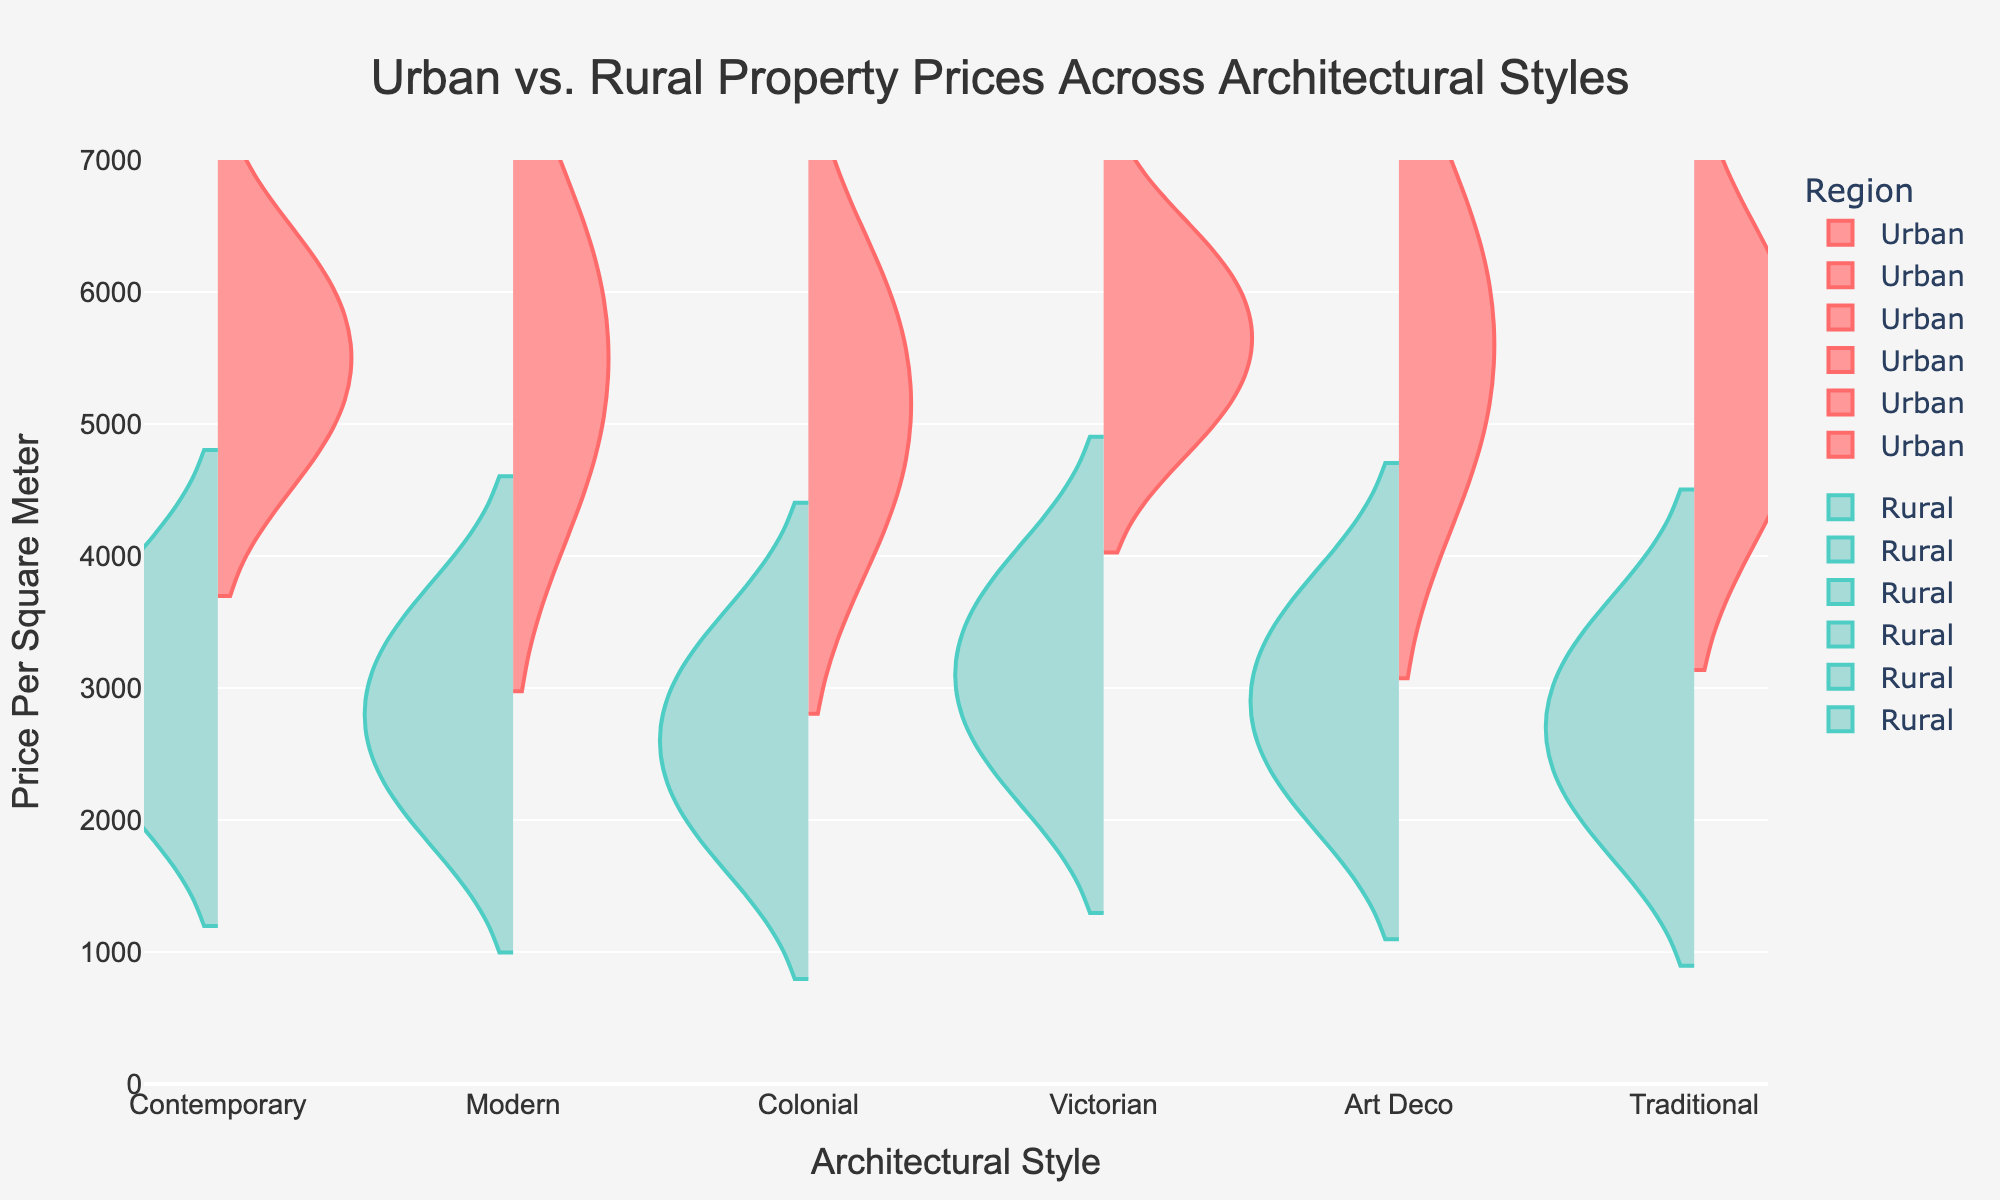Which region has higher property prices for Contemporary Architectural Style? To determine which region has higher property prices for the Contemporary Architectural Style, refer to the corresponding split violin shapes. The Urban section extends higher on the positive side than the Rural section on the negative side.
Answer: Urban What's the range of prices per square meter for Victorian Residential properties in urban areas? For Victorian Residential properties in urban areas, refer to the height of the positive split violin. The prices range from 0 to about 5200 per square meter.
Answer: 0 to 5200 Which architectural style has the smallest difference in property prices between urban and rural areas? Examine the overlap or proximity between the urban and rural segments of each Architectural Style. Art Deco has the smallest difference, with the urban prices slightly exceeding those of rural, but they are close together.
Answer: Art Deco Compare the prices of Commercial properties of Colonial style in urban vs. rural areas. Which is higher and by how much? Check the heights of the split violins for Colonial Commercial properties. The urban prices extend to 5800, while rural prices extend to 3100. The difference is 5800 - 3100.
Answer: Urban by 2700 Which part of the split violin plot is used to represent Rural areas? In general, observe the chart legend or the plot structure. The negative (downward) side of the split violins represents Rural areas.
Answer: Negative side What's the average price per square meter for Traditional Commercial properties in rural areas? For Traditional Commercial properties in rural areas, locate the peak of the downward violin. Prices are centered around 3200.
Answer: ~3200 How do Urban and Rural prices for Modern Residential properties compare? Compare the heights of the split violins for Modern Residential properties. Urban prices reach up to 4800, while Rural prices go up to 2300. Thus, Urban is higher.
Answer: Urban is higher Which region and architectural style combination has the highest observed price per square meter? Refer to the peak of the highest split violin. The Urban Victorian Commercial reaches the highest, at approximately 6300 per square meter.
Answer: Urban Victorian Commercial How much higher is the average price of Contemporary properties in urban areas compared to rural areas? The urban segment for Contemporary properties is centered around 5000, while the rural segment is around 2500. The difference is 5000 - 2500.
Answer: 2500 higher 